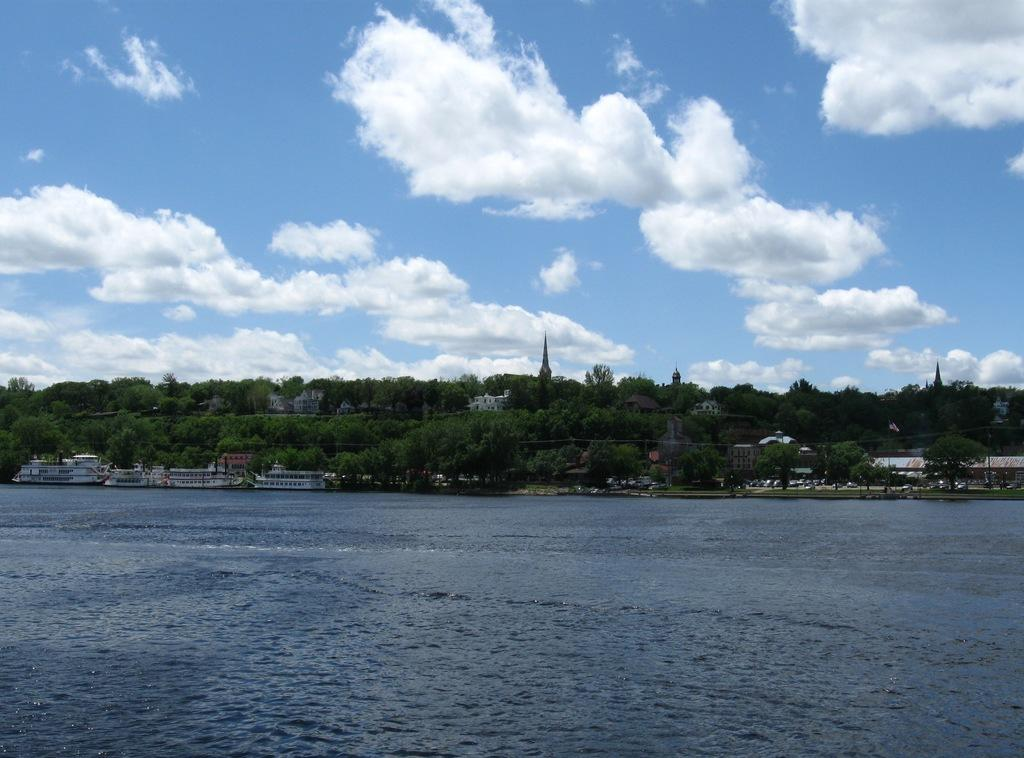What type of structures can be seen in the image? There are buildings in the image. What other natural elements are present in the image? There are trees in the image. What can be seen on the water in the image? Ships are visible on the water on the left side of the image. What is visible in the background of the image? The sky is visible in the background of the image. How many apples are hanging from the trees in the image? There are no apples present in the image; it features trees without any visible fruit. 